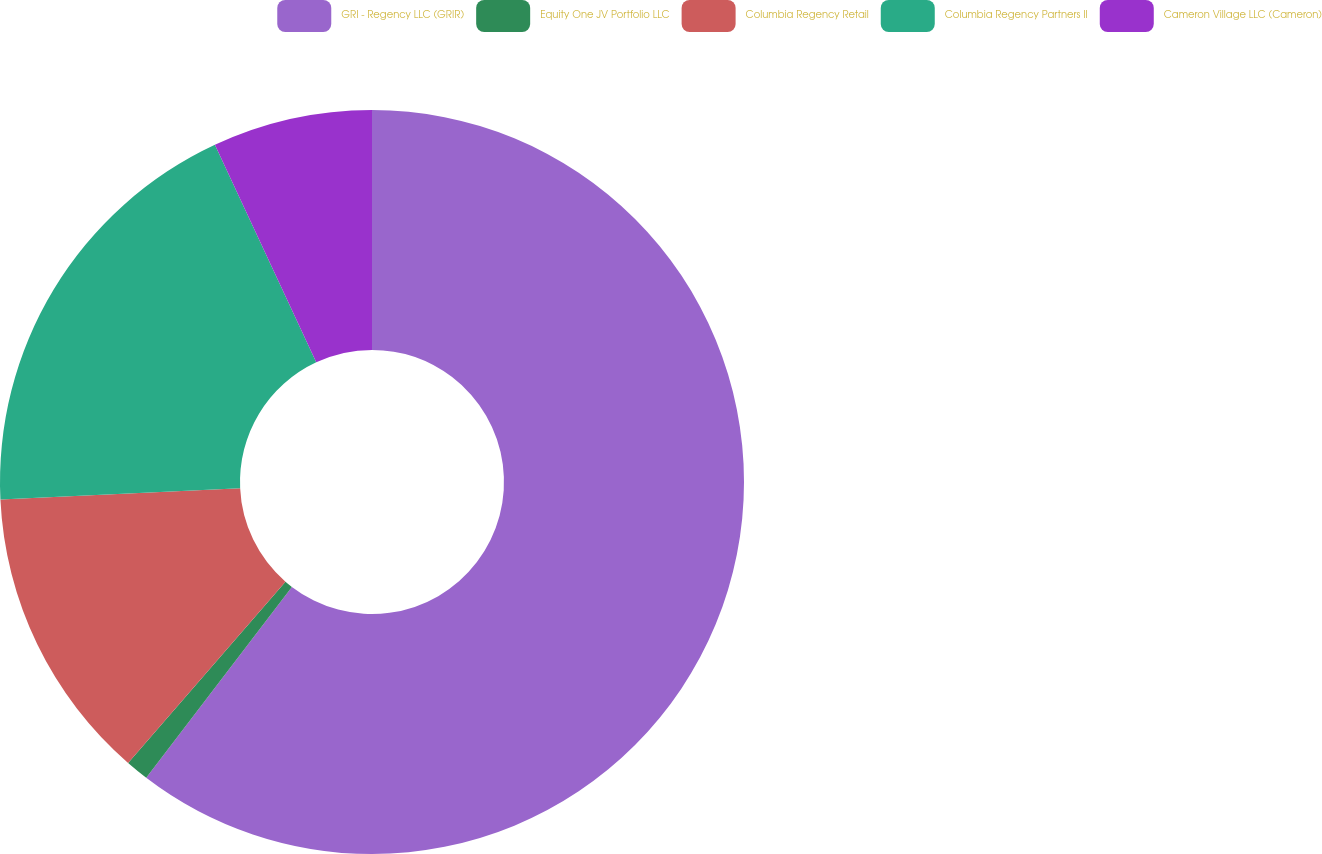<chart> <loc_0><loc_0><loc_500><loc_500><pie_chart><fcel>GRI - Regency LLC (GRIR)<fcel>Equity One JV Portfolio LLC<fcel>Columbia Regency Retail<fcel>Columbia Regency Partners II<fcel>Cameron Village LLC (Cameron)<nl><fcel>60.38%<fcel>1.0%<fcel>12.87%<fcel>18.81%<fcel>6.94%<nl></chart> 